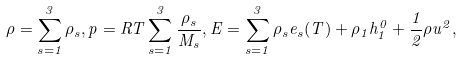<formula> <loc_0><loc_0><loc_500><loc_500>\rho = \sum _ { s = 1 } ^ { 3 } \rho _ { s } , p = R T \sum _ { s = 1 } ^ { 3 } \frac { \rho _ { s } } { M _ { s } } , E = \sum _ { s = 1 } ^ { 3 } \rho _ { s } e _ { s } ( T ) + \rho _ { 1 } h _ { 1 } ^ { 0 } + \frac { 1 } { 2 } \rho u ^ { 2 } ,</formula> 